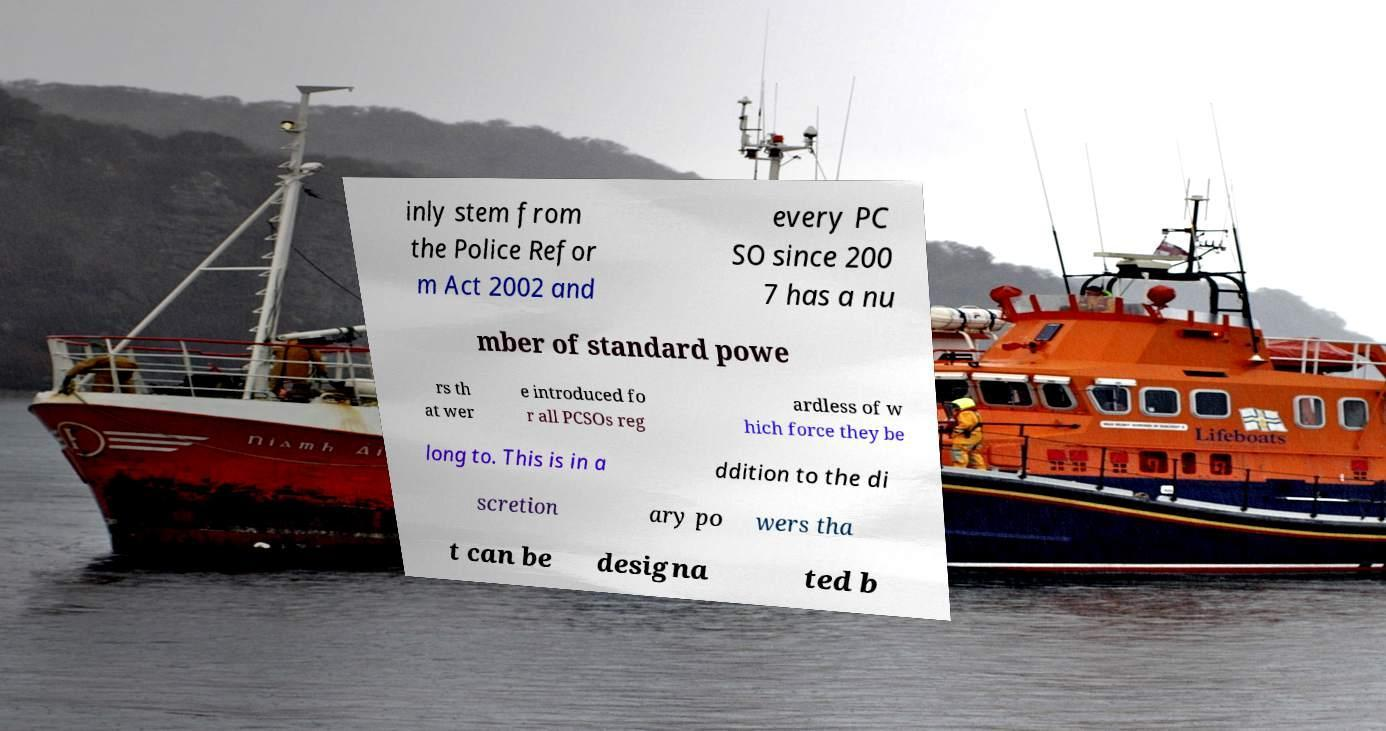I need the written content from this picture converted into text. Can you do that? inly stem from the Police Refor m Act 2002 and every PC SO since 200 7 has a nu mber of standard powe rs th at wer e introduced fo r all PCSOs reg ardless of w hich force they be long to. This is in a ddition to the di scretion ary po wers tha t can be designa ted b 